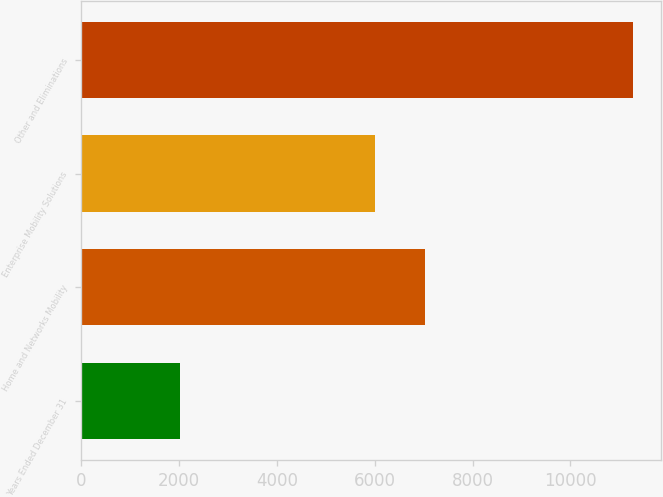Convert chart. <chart><loc_0><loc_0><loc_500><loc_500><bar_chart><fcel>Years Ended December 31<fcel>Home and Networks Mobility<fcel>Enterprise Mobility Solutions<fcel>Other and Eliminations<nl><fcel>2008<fcel>7024<fcel>6000<fcel>11286<nl></chart> 